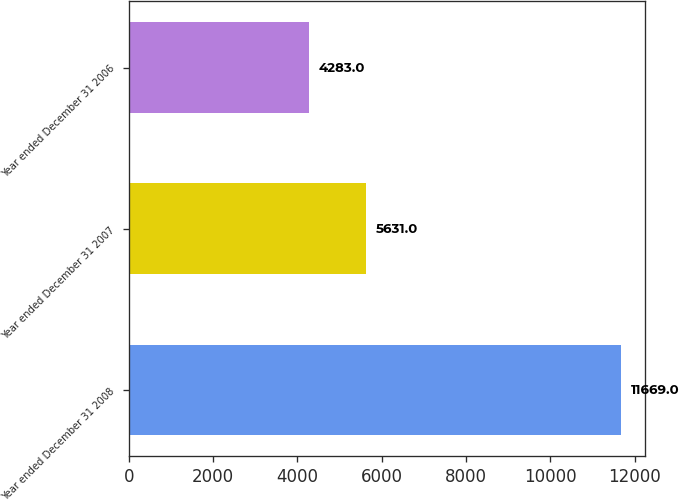Convert chart. <chart><loc_0><loc_0><loc_500><loc_500><bar_chart><fcel>Year ended December 31 2008<fcel>Year ended December 31 2007<fcel>Year ended December 31 2006<nl><fcel>11669<fcel>5631<fcel>4283<nl></chart> 